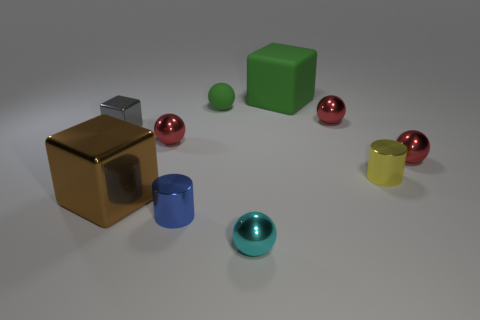Subtract all shiny blocks. How many blocks are left? 1 Subtract all green cubes. How many red spheres are left? 3 Subtract all green cubes. How many cubes are left? 2 Subtract all blocks. How many objects are left? 7 Subtract 2 spheres. How many spheres are left? 3 Subtract all purple cubes. Subtract all yellow cylinders. How many cubes are left? 3 Add 3 small balls. How many small balls are left? 8 Add 5 gray shiny blocks. How many gray shiny blocks exist? 6 Subtract 0 purple cubes. How many objects are left? 10 Subtract all big rubber cubes. Subtract all large brown objects. How many objects are left? 8 